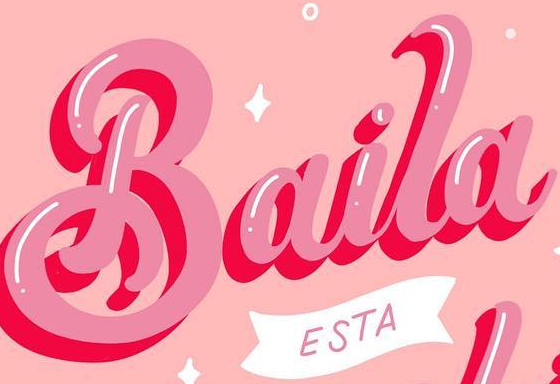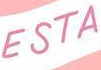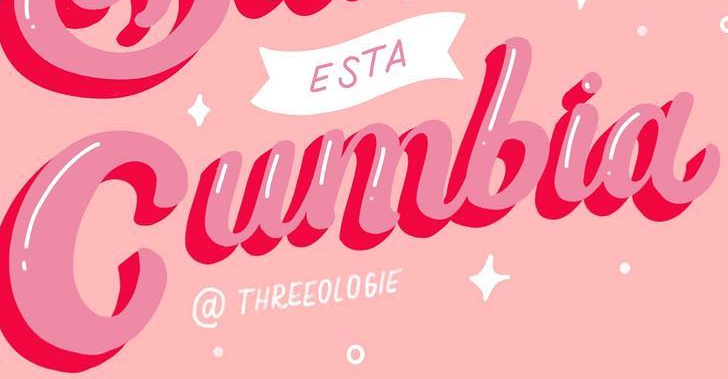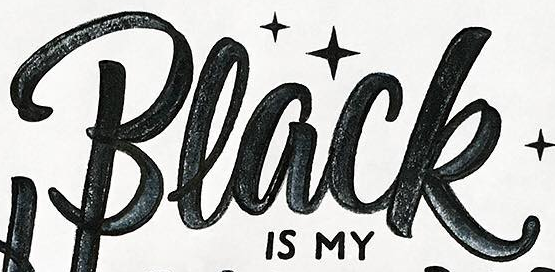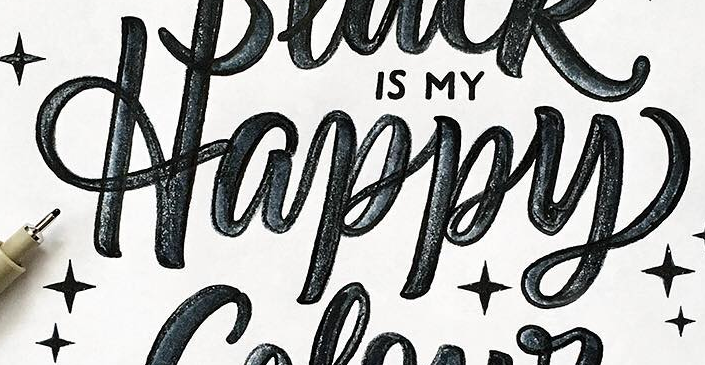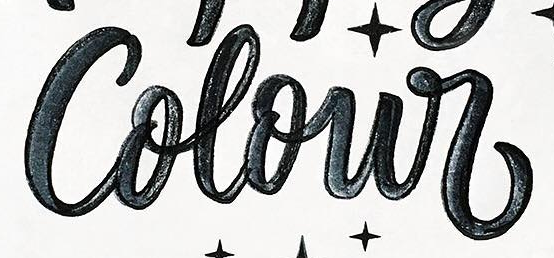Identify the words shown in these images in order, separated by a semicolon. Baila; ESTA; Cumbia; Black; Happy; Colour 